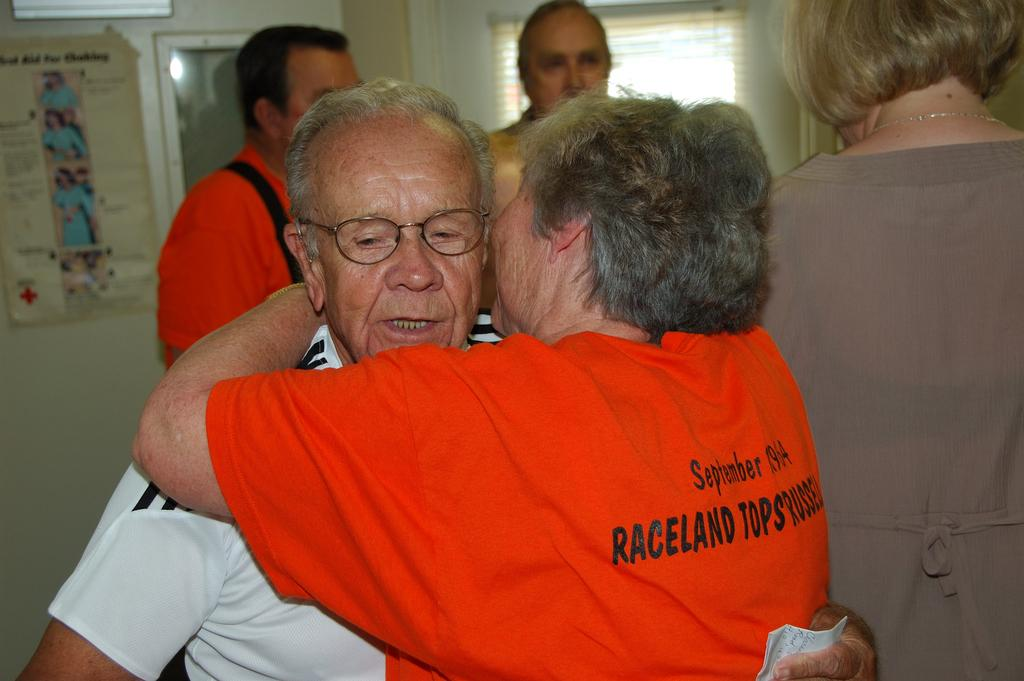How many people are in the image? There is a group of people in the image, but the exact number cannot be determined from the provided facts. What can be seen in the background of the image? There is a wall, a poster, and other objects visible in the background of the image. What type of farm animals can be seen in the image? There is no farm or farm animals present in the image. How does the brain appear in the image? There is no brain visible in the image. 